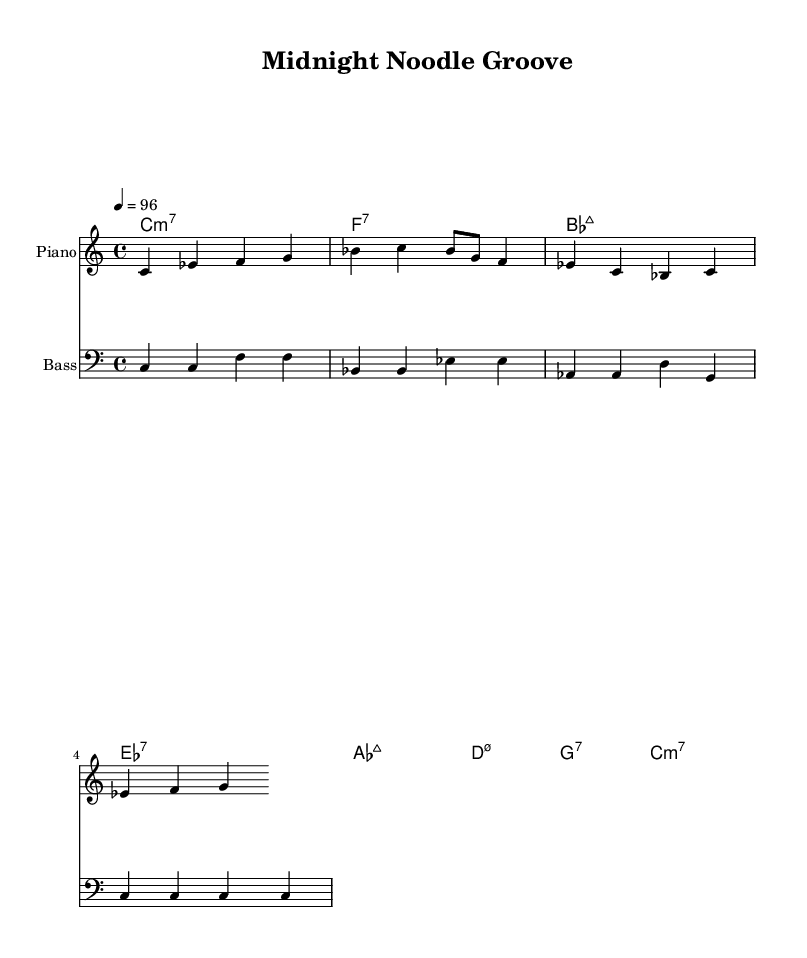What is the key signature of this music? The key signature is C major, which has no sharps or flats.
Answer: C major What is the time signature of this piece? The time signature is indicated as 4/4, meaning there are four beats in a measure.
Answer: 4/4 What is the tempo marking for this piece? The tempo marking is indicated by "4 = 96," meaning there are 96 beats per minute.
Answer: 96 How many measures are in the melody? By counting the measures in the melody section, we see there are seven measures total.
Answer: 7 What type of seventh chord is played in the first measure? The first measure has a C minor seventh chord, characterized by the chord symbol "c1:m7."
Answer: C minor seventh How does the bass line interact with the melody? The bass line provides a harmonic foundation that complements the melody by outlining the chord tones and creating rhythmic support.
Answer: Complements melody What kind of feeling does the music create, based on its elements? The combination of the groove, syncopated rhythms, and laid-back feel of the melodies and bass lines evokes a relaxed and enjoyable nighttime atmosphere, fitting for a ramen shop.
Answer: Relaxed atmosphere 